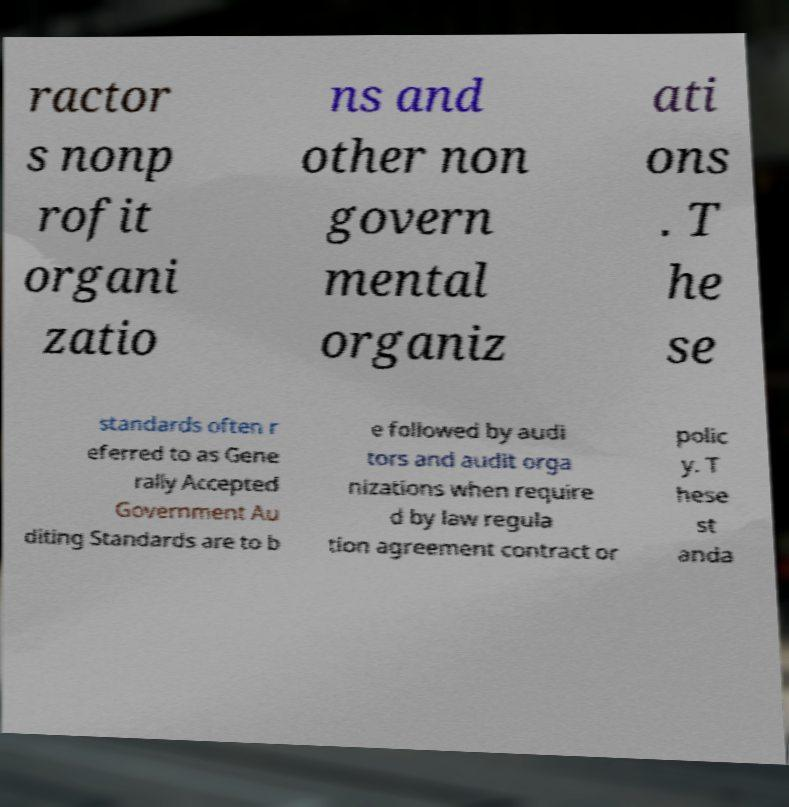Could you extract and type out the text from this image? ractor s nonp rofit organi zatio ns and other non govern mental organiz ati ons . T he se standards often r eferred to as Gene rally Accepted Government Au diting Standards are to b e followed by audi tors and audit orga nizations when require d by law regula tion agreement contract or polic y. T hese st anda 